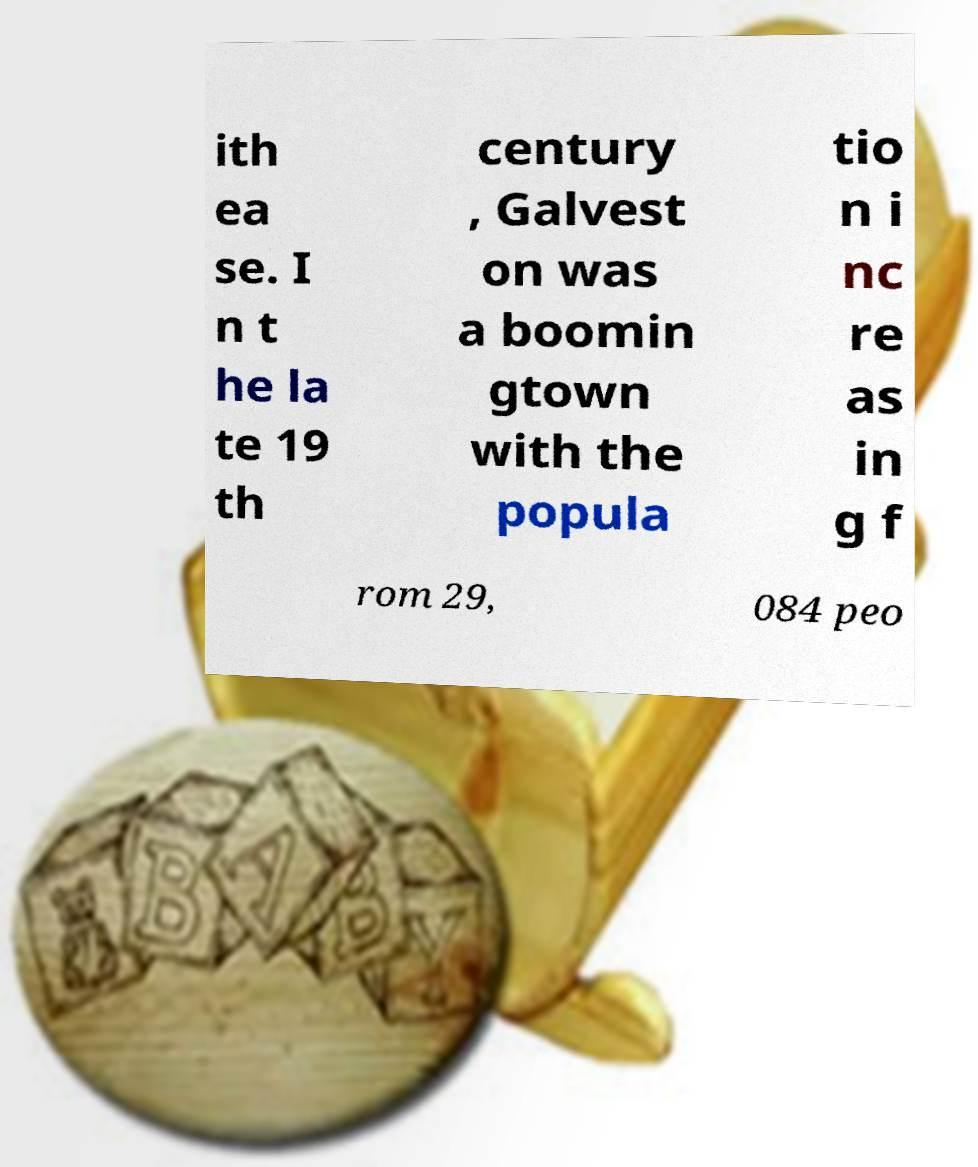For documentation purposes, I need the text within this image transcribed. Could you provide that? ith ea se. I n t he la te 19 th century , Galvest on was a boomin gtown with the popula tio n i nc re as in g f rom 29, 084 peo 